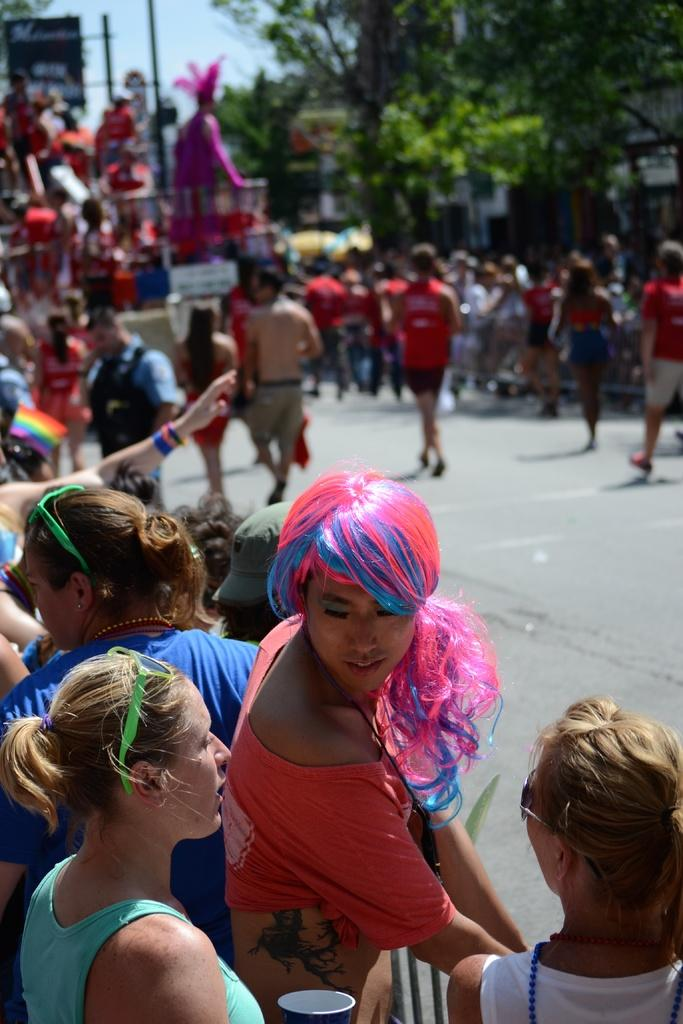How many people are in the image? There is a group of people in the image. Where are some of the people located in the image? Some people are on the road in the image. What type of natural vegetation can be seen in the image? There are trees in the image. What type of man-made objects can be seen in the image? There are poles in the image, as well as other objects. What is visible in the background of the image? The sky is visible in the background of the image. What type of mask is being worn by the people in the image? There is no mention of masks in the image. 